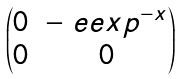Convert formula to latex. <formula><loc_0><loc_0><loc_500><loc_500>\begin{pmatrix} 0 & - \ e e x p ^ { - x } \\ 0 & 0 \end{pmatrix}</formula> 